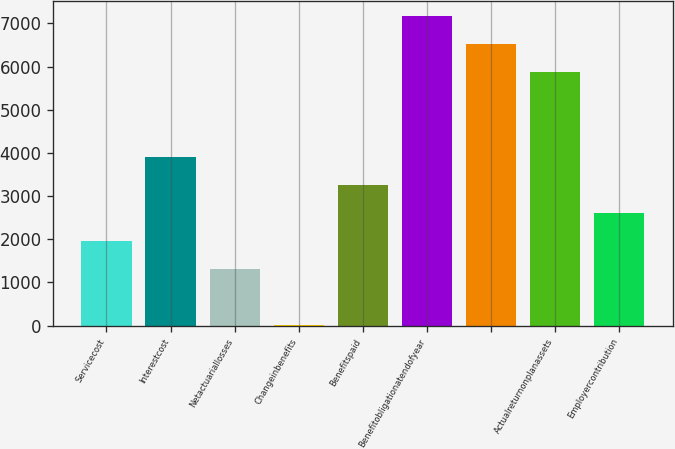Convert chart. <chart><loc_0><loc_0><loc_500><loc_500><bar_chart><fcel>Servicecost<fcel>Interestcost<fcel>Netactuariallosses<fcel>Changeinbenefits<fcel>Benefitspaid<fcel>Benefitobligationatendofyear<fcel>Unnamed: 6<fcel>Actualreturnonplanassets<fcel>Employercontribution<nl><fcel>1956.7<fcel>3912.4<fcel>1304.8<fcel>1<fcel>3260.5<fcel>7171.9<fcel>6520<fcel>5868.1<fcel>2608.6<nl></chart> 